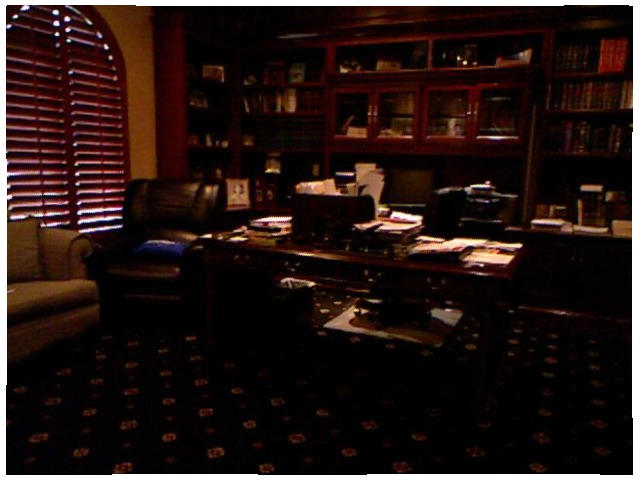<image>
Can you confirm if the books is above the chair? No. The books is not positioned above the chair. The vertical arrangement shows a different relationship. 